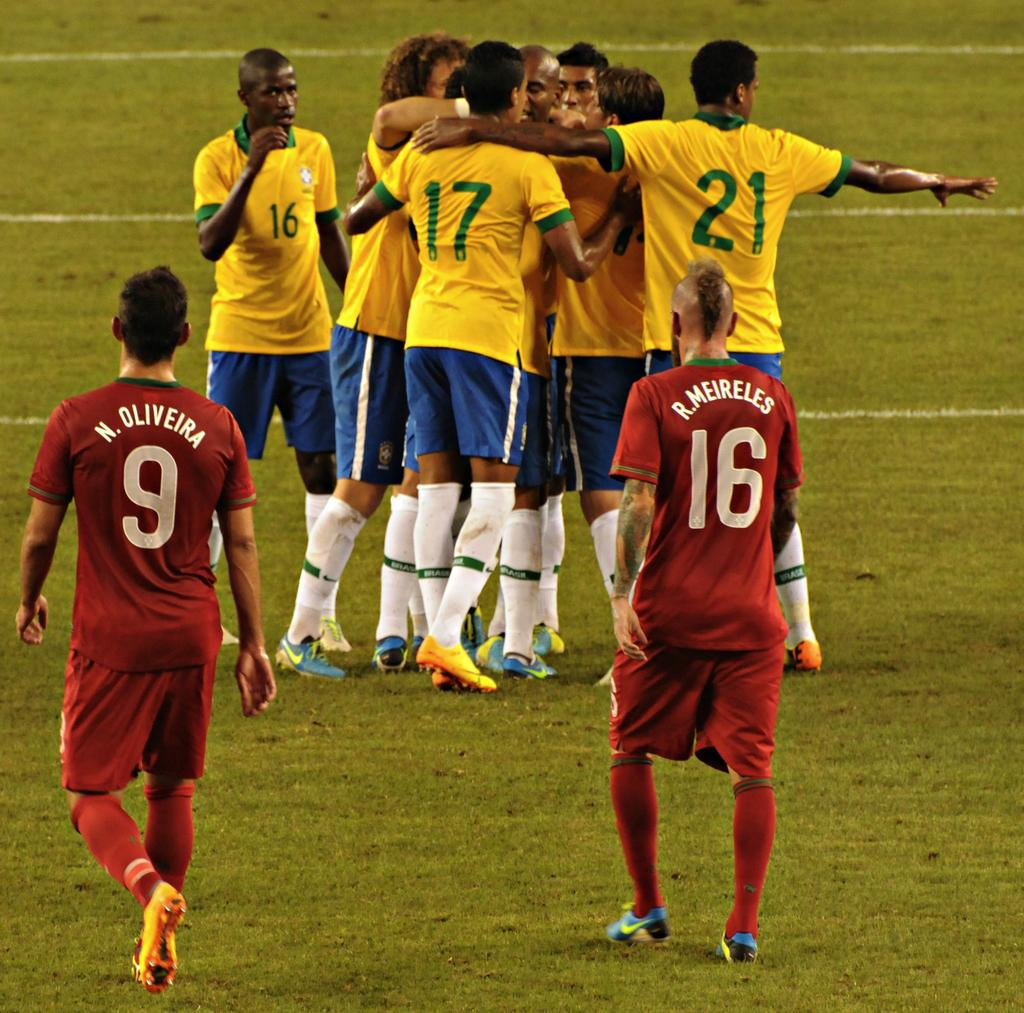<image>
Create a compact narrative representing the image presented. Numbers 9 and 16 of players Oliveira and Meireles are shown here. 